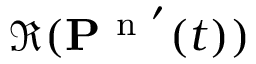<formula> <loc_0><loc_0><loc_500><loc_500>\Re ( P ^ { n ^ { \prime } } ( t ) )</formula> 